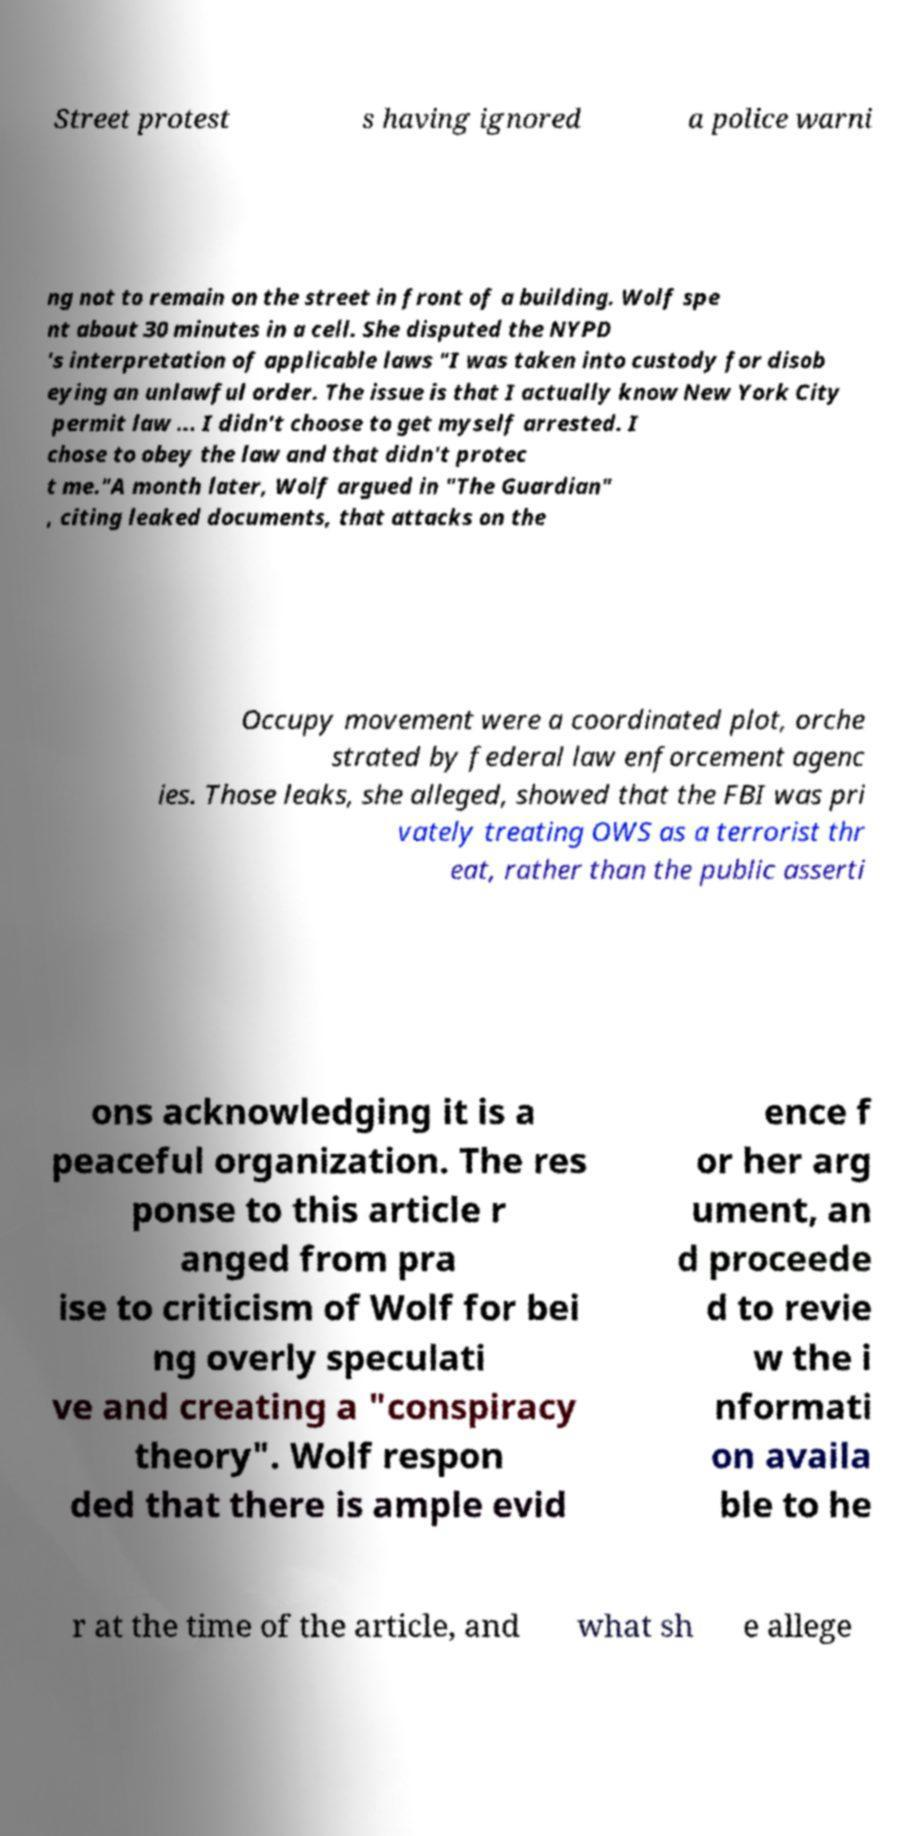Please read and relay the text visible in this image. What does it say? Street protest s having ignored a police warni ng not to remain on the street in front of a building. Wolf spe nt about 30 minutes in a cell. She disputed the NYPD 's interpretation of applicable laws "I was taken into custody for disob eying an unlawful order. The issue is that I actually know New York City permit law ... I didn't choose to get myself arrested. I chose to obey the law and that didn't protec t me."A month later, Wolf argued in "The Guardian" , citing leaked documents, that attacks on the Occupy movement were a coordinated plot, orche strated by federal law enforcement agenc ies. Those leaks, she alleged, showed that the FBI was pri vately treating OWS as a terrorist thr eat, rather than the public asserti ons acknowledging it is a peaceful organization. The res ponse to this article r anged from pra ise to criticism of Wolf for bei ng overly speculati ve and creating a "conspiracy theory". Wolf respon ded that there is ample evid ence f or her arg ument, an d proceede d to revie w the i nformati on availa ble to he r at the time of the article, and what sh e allege 